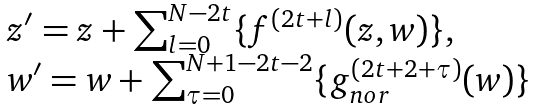Convert formula to latex. <formula><loc_0><loc_0><loc_500><loc_500>\begin{array} { l l } & z ^ { \prime } = z + \sum _ { l = 0 } ^ { N - 2 t } \{ f ^ { ( 2 t + l ) } ( z , w ) \} , \ \\ & w ^ { \prime } = w + \sum _ { \tau = 0 } ^ { N + 1 - 2 t - 2 } \{ g _ { n o r } ^ { ( 2 t + 2 + \tau ) } ( w ) \} \end{array}</formula> 